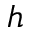Convert formula to latex. <formula><loc_0><loc_0><loc_500><loc_500>h</formula> 